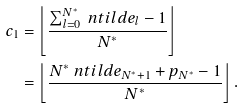Convert formula to latex. <formula><loc_0><loc_0><loc_500><loc_500>c _ { 1 } & = \left \lfloor \frac { \sum _ { l = 0 } ^ { N ^ { * } } \ n t i l d e _ { l } - 1 } { N ^ { * } } \right \rfloor \\ & = \left \lfloor \frac { N ^ { * } \ n t i l d e _ { N ^ { * } + 1 } + p _ { N ^ { * } } - 1 } { N ^ { * } } \right \rfloor .</formula> 